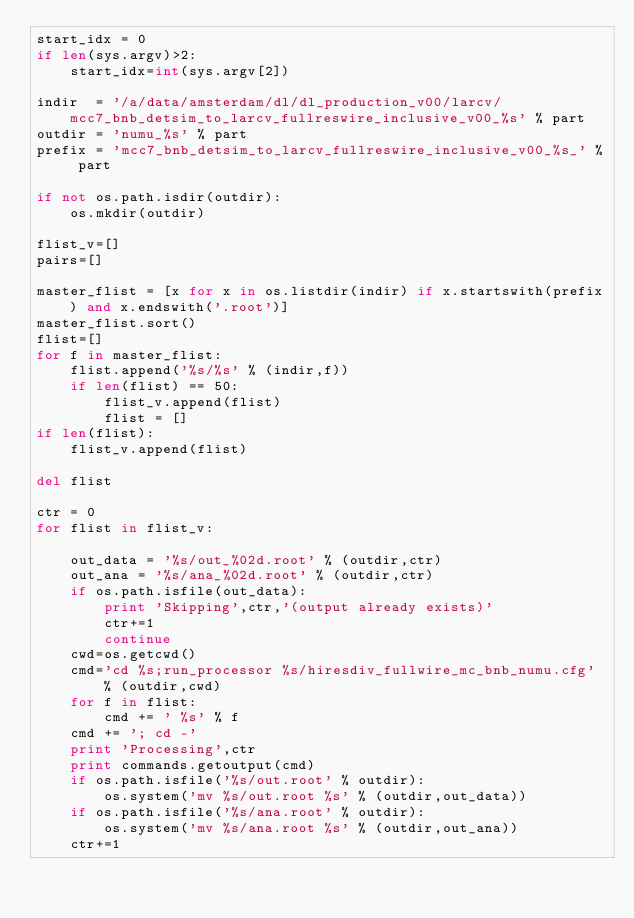<code> <loc_0><loc_0><loc_500><loc_500><_Python_>start_idx = 0
if len(sys.argv)>2:
    start_idx=int(sys.argv[2])

indir  = '/a/data/amsterdam/dl/dl_production_v00/larcv/mcc7_bnb_detsim_to_larcv_fullreswire_inclusive_v00_%s' % part
outdir = 'numu_%s' % part
prefix = 'mcc7_bnb_detsim_to_larcv_fullreswire_inclusive_v00_%s_' % part

if not os.path.isdir(outdir):
    os.mkdir(outdir)

flist_v=[]
pairs=[]

master_flist = [x for x in os.listdir(indir) if x.startswith(prefix) and x.endswith('.root')]
master_flist.sort()
flist=[]
for f in master_flist:
    flist.append('%s/%s' % (indir,f))
    if len(flist) == 50:
        flist_v.append(flist)
        flist = []
if len(flist):
    flist_v.append(flist)

del flist

ctr = 0
for flist in flist_v:

    out_data = '%s/out_%02d.root' % (outdir,ctr)
    out_ana = '%s/ana_%02d.root' % (outdir,ctr)
    if os.path.isfile(out_data):
        print 'Skipping',ctr,'(output already exists)'
        ctr+=1
        continue
    cwd=os.getcwd()
    cmd='cd %s;run_processor %s/hiresdiv_fullwire_mc_bnb_numu.cfg' % (outdir,cwd)
    for f in flist:
        cmd += ' %s' % f
    cmd += '; cd -'
    print 'Processing',ctr
    print commands.getoutput(cmd)
    if os.path.isfile('%s/out.root' % outdir):
        os.system('mv %s/out.root %s' % (outdir,out_data))
    if os.path.isfile('%s/ana.root' % outdir):
        os.system('mv %s/ana.root %s' % (outdir,out_ana))
    ctr+=1

</code> 